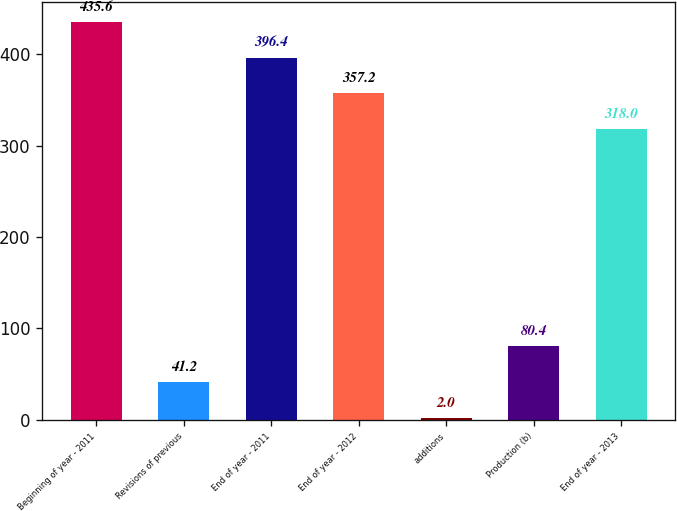Convert chart to OTSL. <chart><loc_0><loc_0><loc_500><loc_500><bar_chart><fcel>Beginning of year - 2011<fcel>Revisions of previous<fcel>End of year - 2011<fcel>End of year - 2012<fcel>additions<fcel>Production (b)<fcel>End of year - 2013<nl><fcel>435.6<fcel>41.2<fcel>396.4<fcel>357.2<fcel>2<fcel>80.4<fcel>318<nl></chart> 